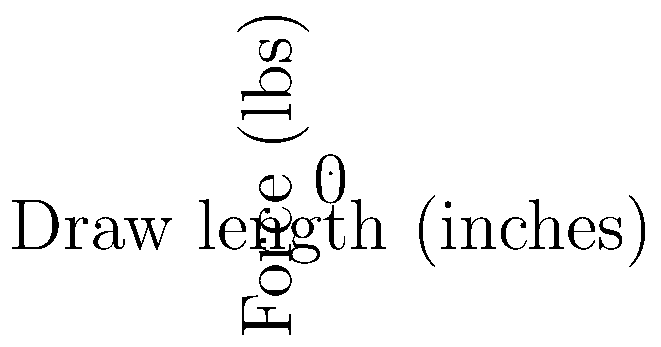Based on the graph showing the force-draw curves for three different bows, calculate the force required to draw the 60# @ 28" bow to a draw length of 25 inches. To solve this problem, we'll follow these steps:

1) First, identify the line representing the 60# @ 28" bow. This is the red line on the graph.

2) The equation for this line is of the form $y = mx$, where:
   - $y$ is the force in pounds
   - $x$ is the draw length in inches
   - $m$ is the slope of the line

3) We can calculate the slope using the given information:
   At 28 inches, the force is 60 pounds.
   Therefore, $m = 60 / 28 = 15/7 \approx 2.14$ pounds per inch

4) The equation for this bow's force-draw curve is thus:
   $F = (15/7) * L$
   Where $F$ is force in pounds and $L$ is draw length in inches

5) To find the force at 25 inches, we substitute $L = 25$ into our equation:
   $F = (15/7) * 25 = 375/7 \approx 53.57$ pounds

Therefore, the force required to draw the 60# @ 28" bow to 25 inches is approximately 53.57 pounds.
Answer: $53.57$ pounds 